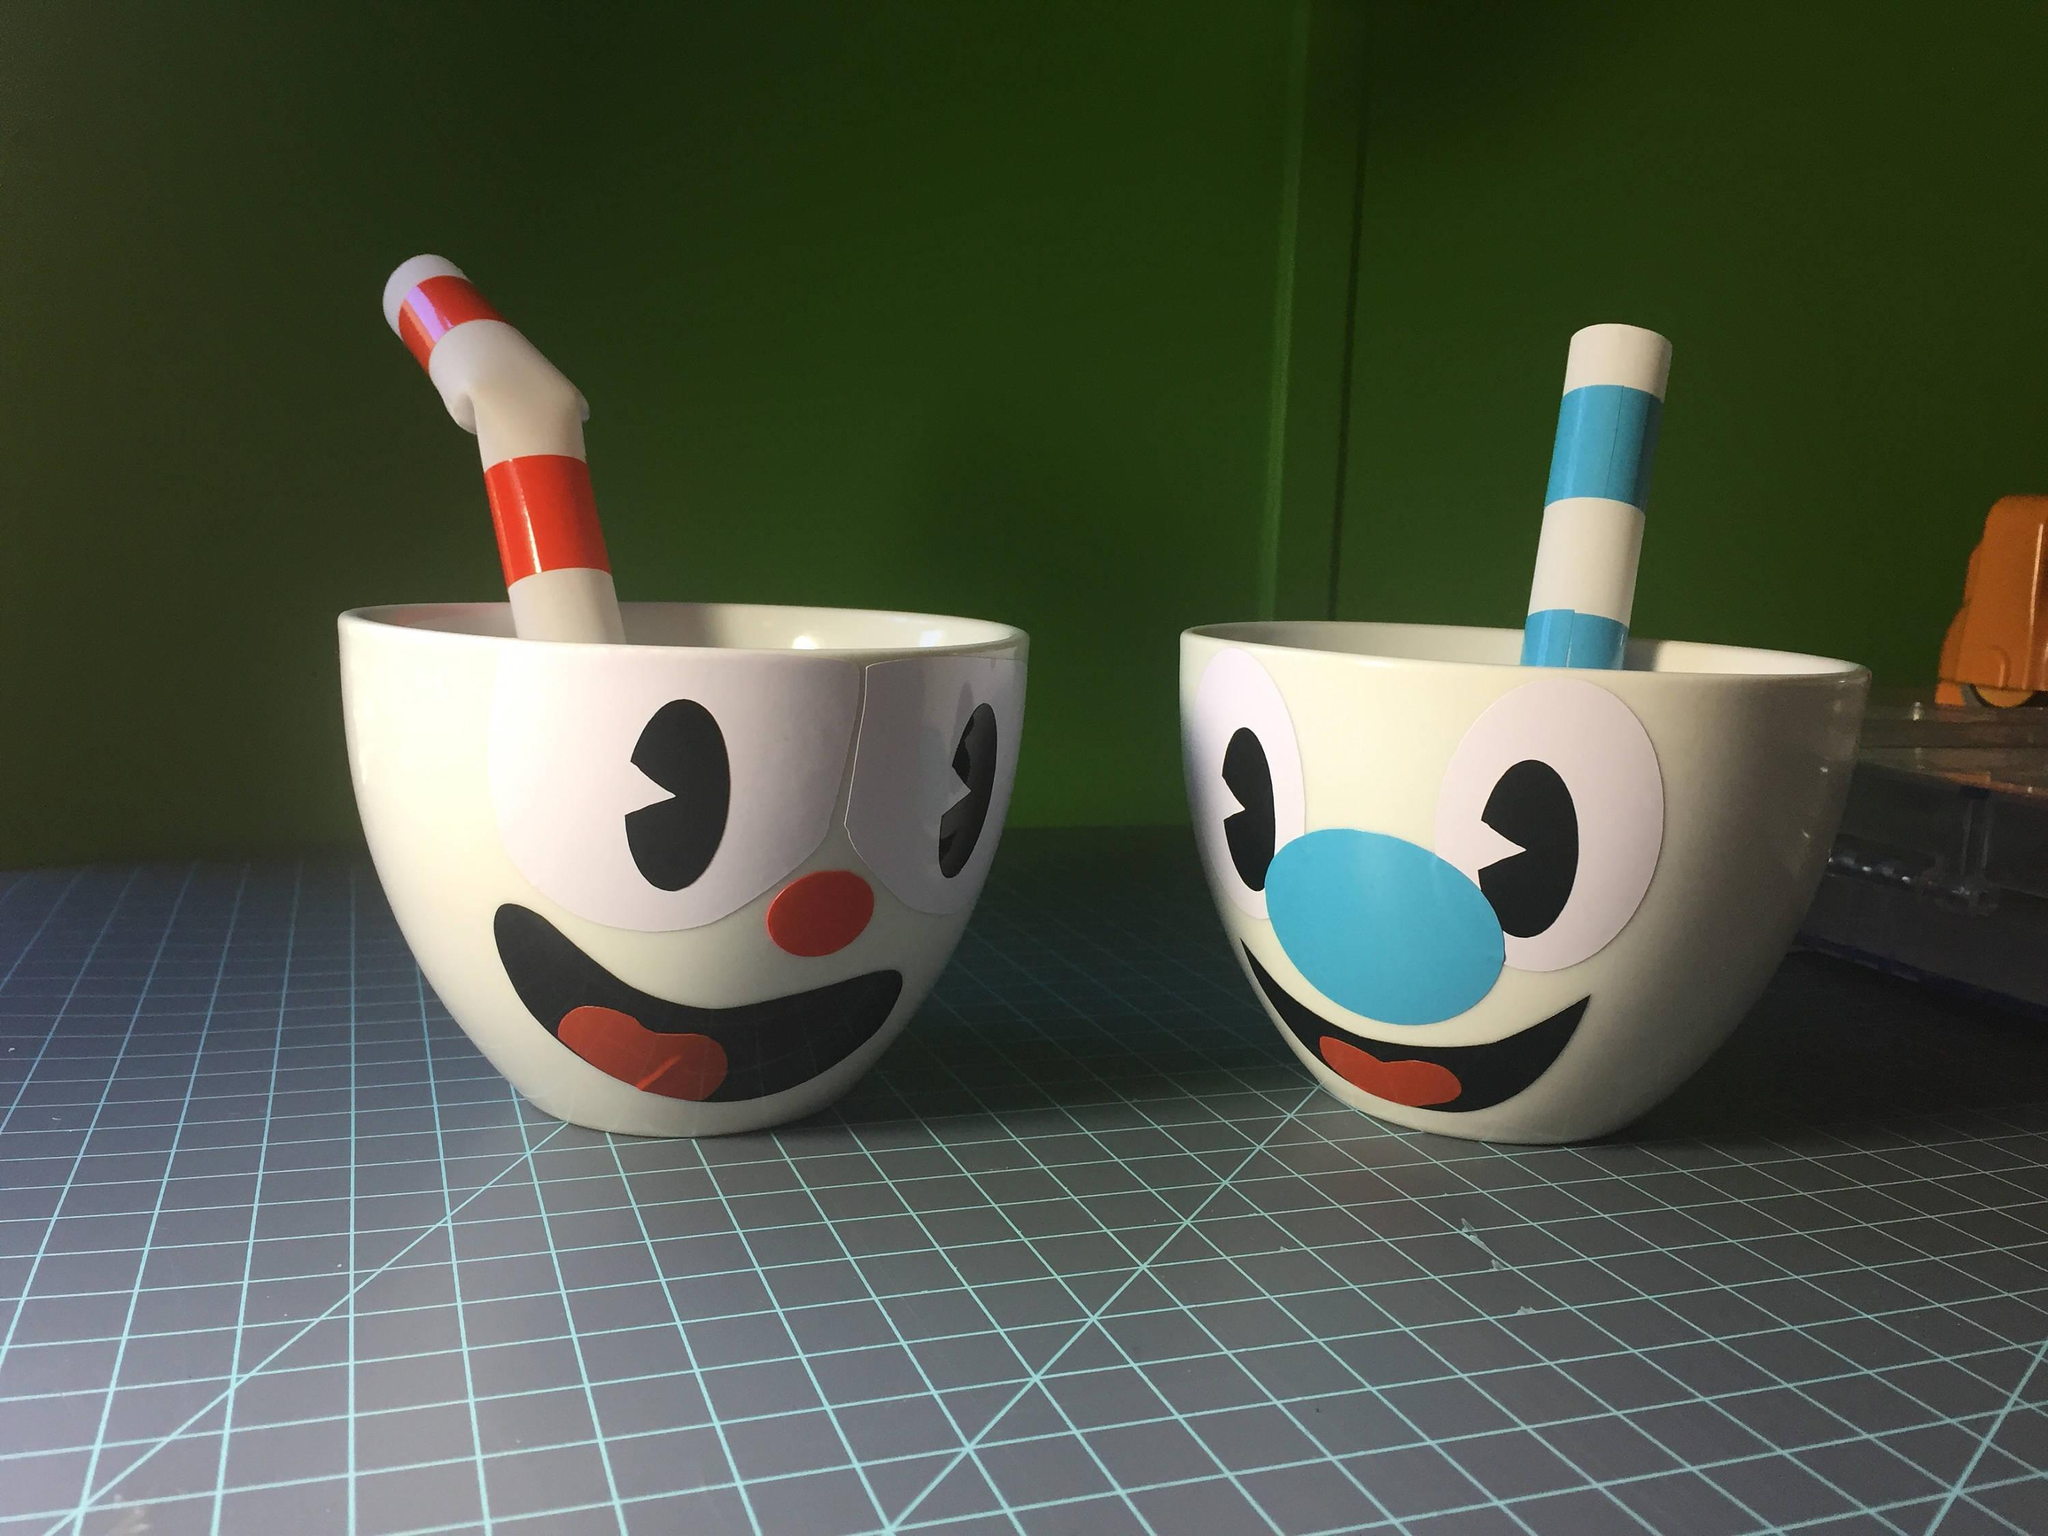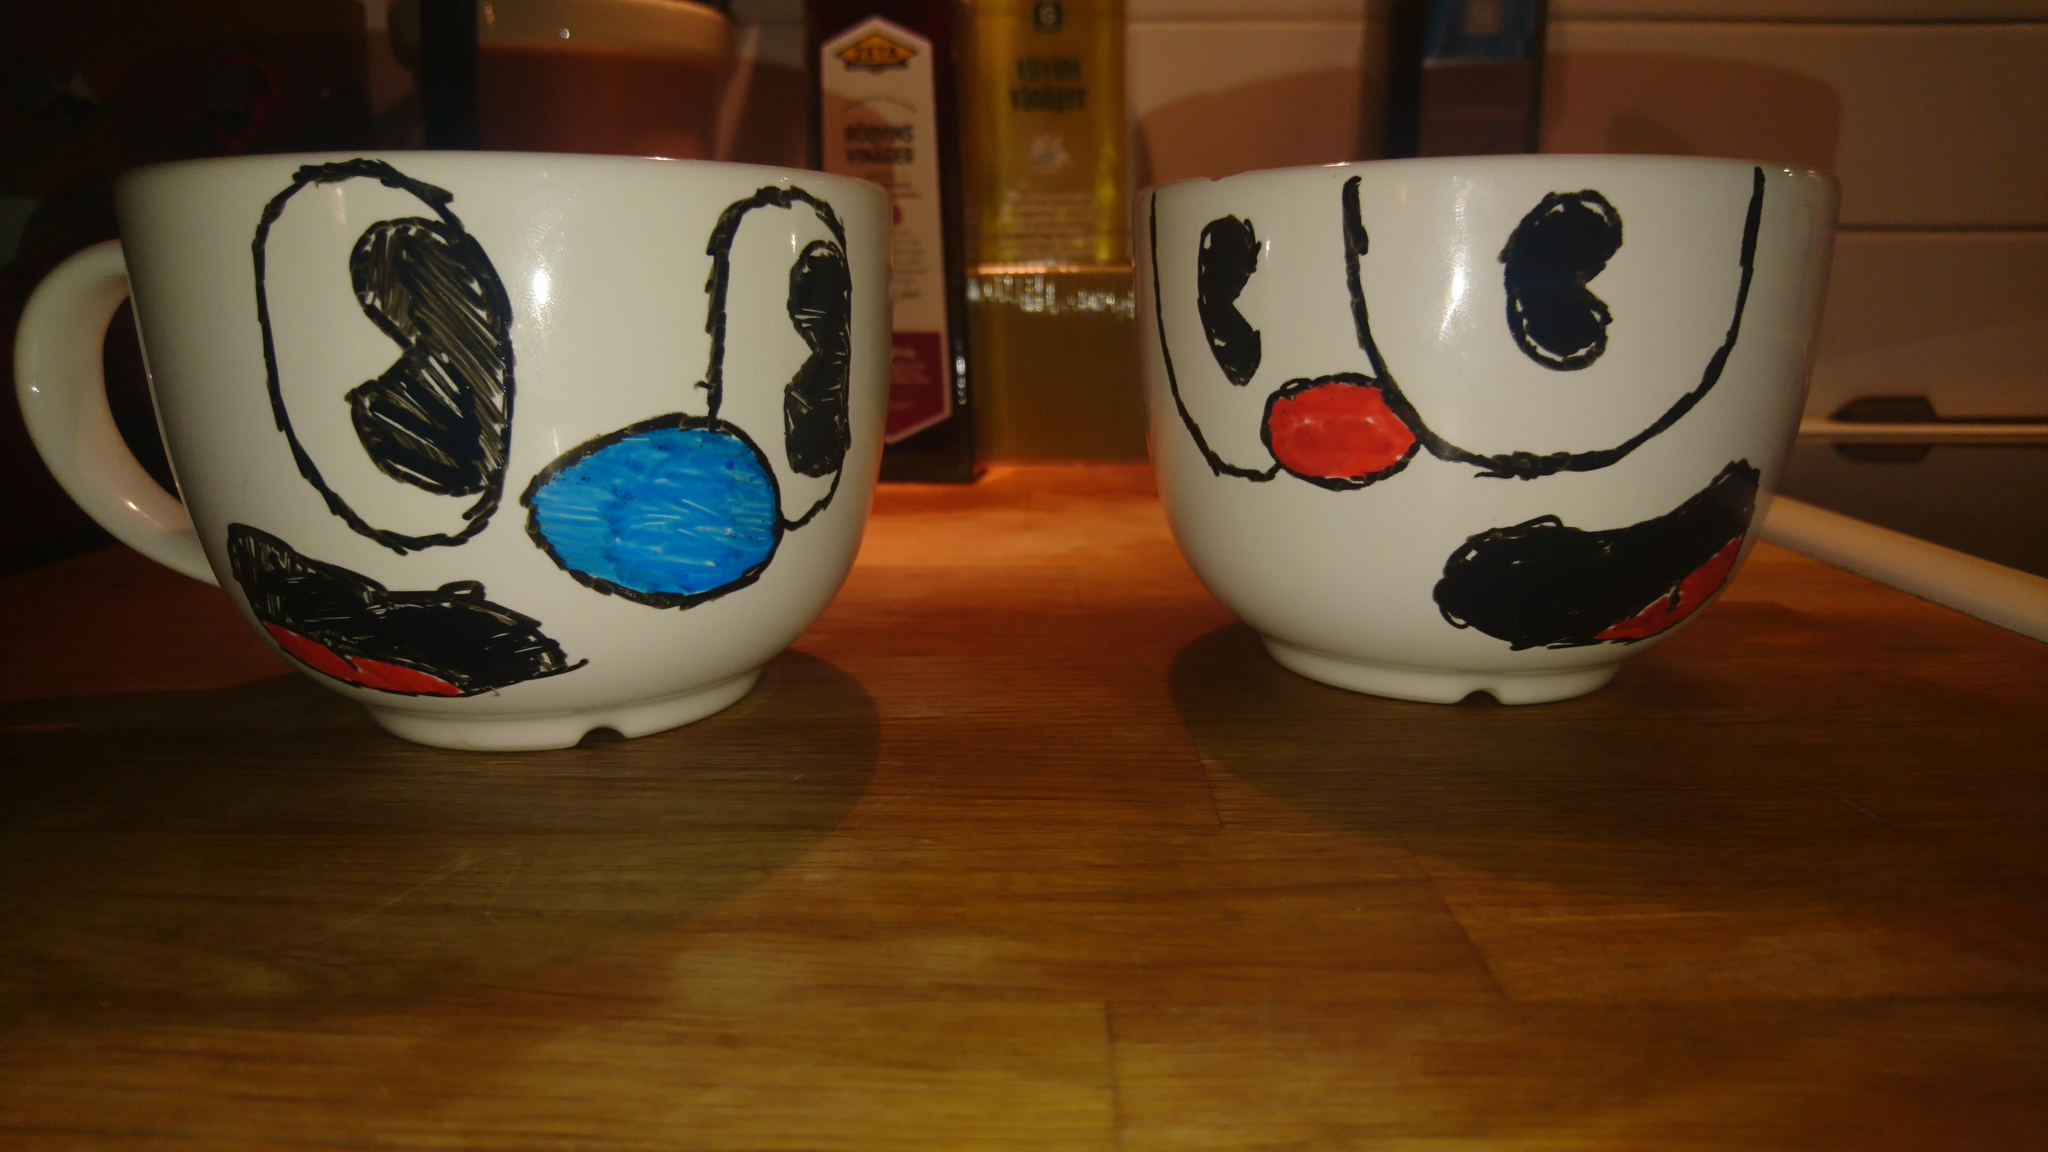The first image is the image on the left, the second image is the image on the right. For the images displayed, is the sentence "An equal number of cups with a face design are in each image, a fat striped straw in each cup." factually correct? Answer yes or no. No. The first image is the image on the left, the second image is the image on the right. Analyze the images presented: Is the assertion "The left and right image contains the same number porcelain of smiley face cups." valid? Answer yes or no. Yes. 